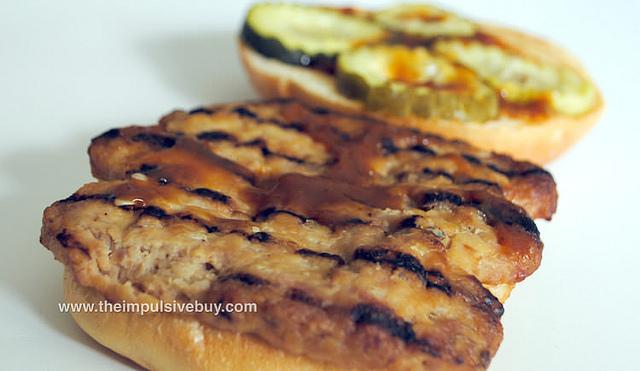Is this edible?
Be succinct. Yes. How many pickles are on the bun?
Write a very short answer. 4. Is there barbecue sauce?
Keep it brief. Yes. 